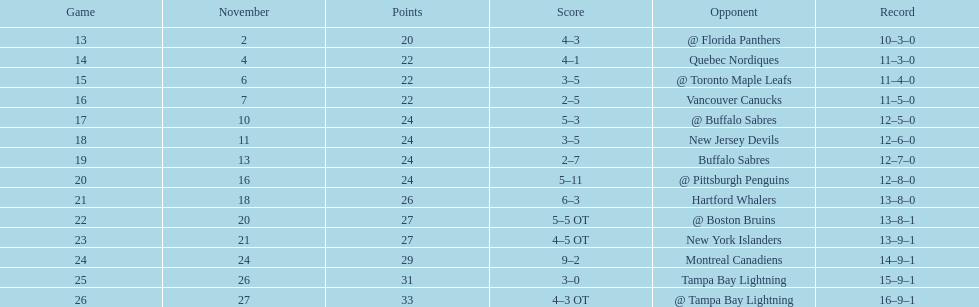The 1993-1994 flyers missed the playoffs again. how many consecutive seasons up until 93-94 did the flyers miss the playoffs? 5. 